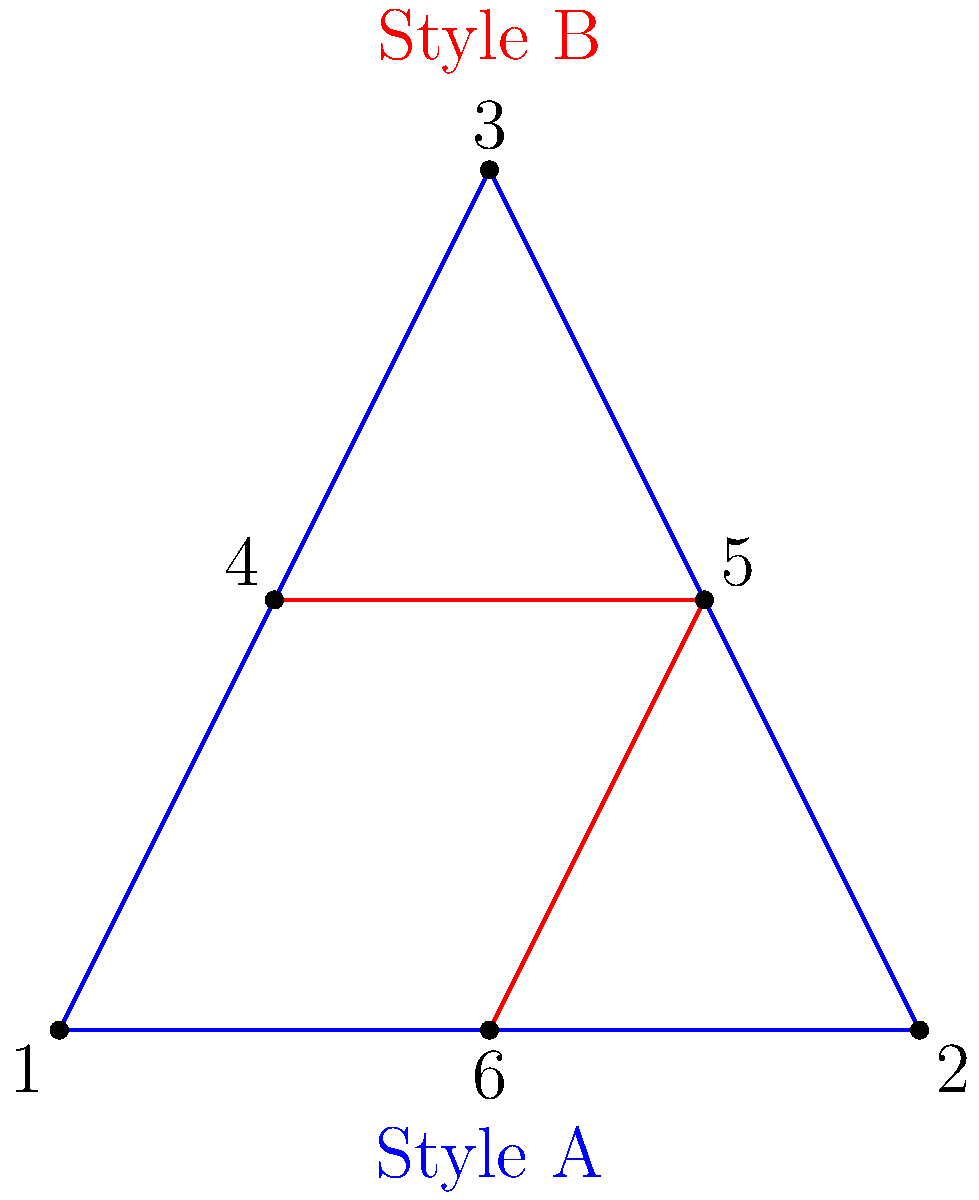In comparing character design styles for a graphic novel series, which points in Style A (blue triangle) correspond to points 4, 5, and 6 in Style B (red triangle) to maintain consistency across designs? To determine the corresponding points between Style A and Style B for consistent character design:

1. Observe that both triangles share the same vertical axis of symmetry.
2. Point 6 in Style B is at the bottom center, corresponding to the midpoint of the base in Style A, which is point 1.
3. Points 4 and 5 in Style B form the top two vertices of the red triangle.
4. To maintain proportional relationships, these should correspond to points equidistant from the center on the blue triangle.
5. The only points that satisfy this condition in Style A are points 2 and 3.
6. Therefore, point 4 in Style B corresponds to point 2 in Style A.
7. Similarly, point 5 in Style B corresponds to point 3 in Style A.

Thus, the correspondence for consistent design is:
- Point 4 (Style B) → Point 2 (Style A)
- Point 5 (Style B) → Point 3 (Style A)
- Point 6 (Style B) → Point 1 (Style A)
Answer: 2, 3, 1 